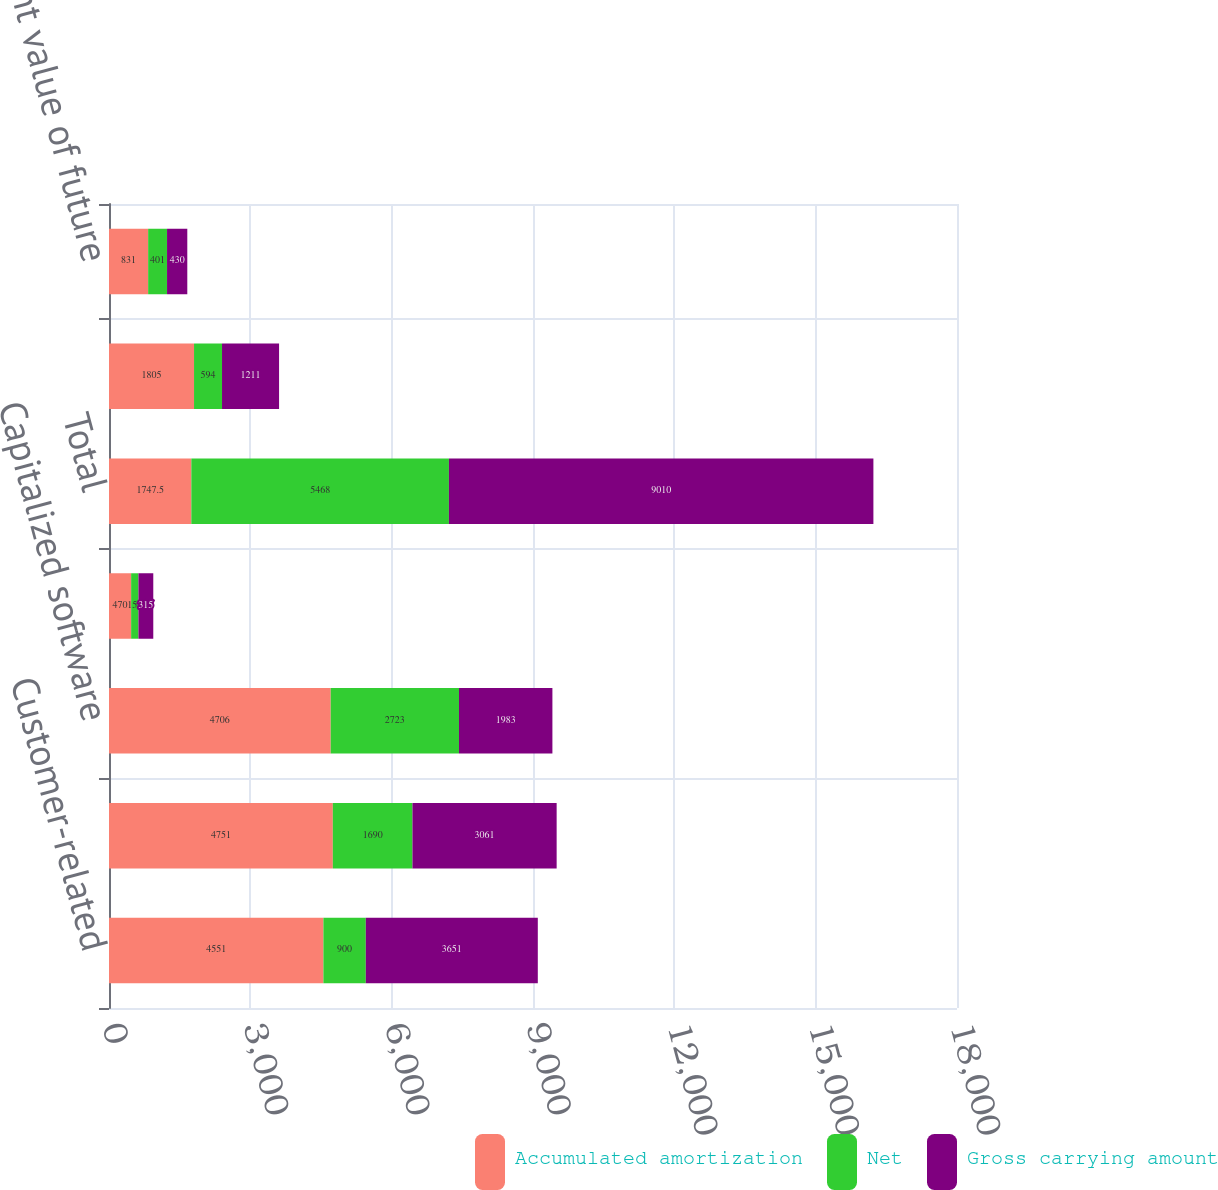Convert chart to OTSL. <chart><loc_0><loc_0><loc_500><loc_500><stacked_bar_chart><ecel><fcel>Customer-related<fcel>Patents licenses and<fcel>Capitalized software<fcel>All other<fcel>Total<fcel>Lease valuations<fcel>Present value of future<nl><fcel>Accumulated amortization<fcel>4551<fcel>4751<fcel>4706<fcel>470<fcel>1747.5<fcel>1805<fcel>831<nl><fcel>Net<fcel>900<fcel>1690<fcel>2723<fcel>155<fcel>5468<fcel>594<fcel>401<nl><fcel>Gross carrying amount<fcel>3651<fcel>3061<fcel>1983<fcel>315<fcel>9010<fcel>1211<fcel>430<nl></chart> 